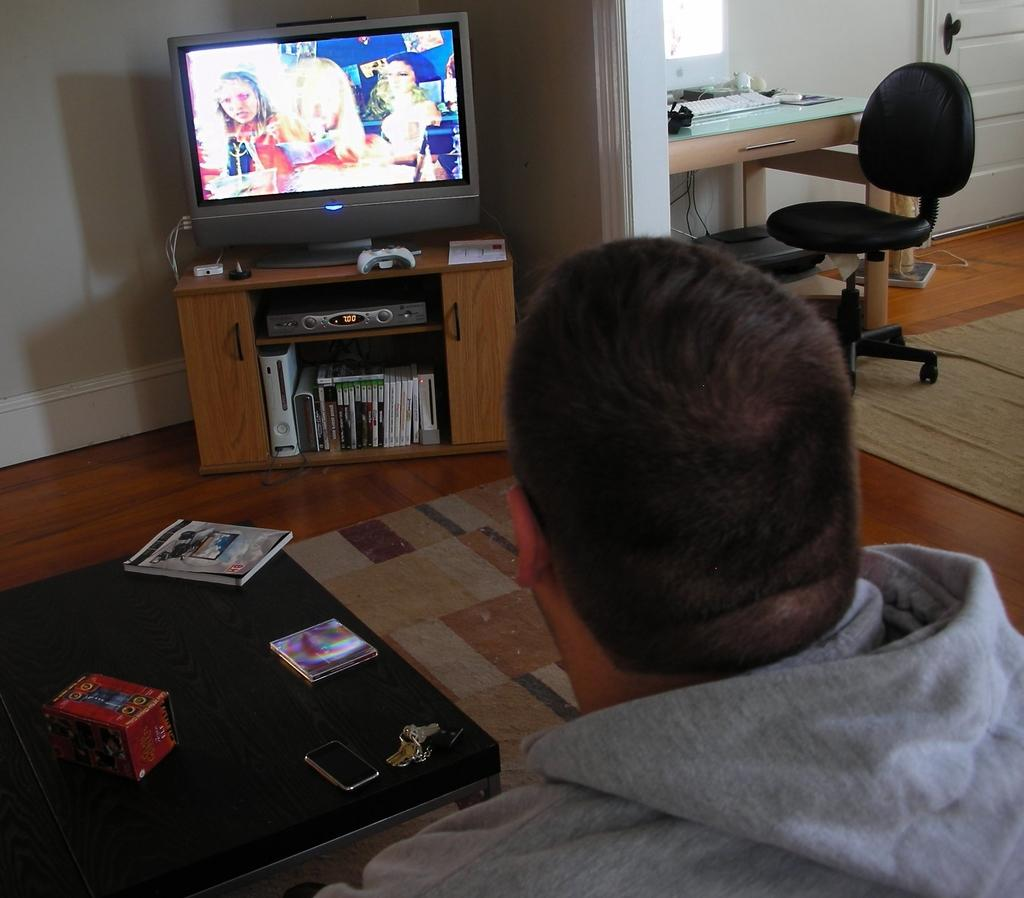Who is present in the image? There is a man in the image. What is the man doing in the image? The man is sitting in front of a table and watching TV. Where is the TV located in the image? The TV is on the table in the image. What piece of furniture is the man using to sit? There is a chair in the image. How many people are in the crowd watching the match in the image? There is no crowd or match present in the image; it features a man sitting in front of a table and watching TV. 